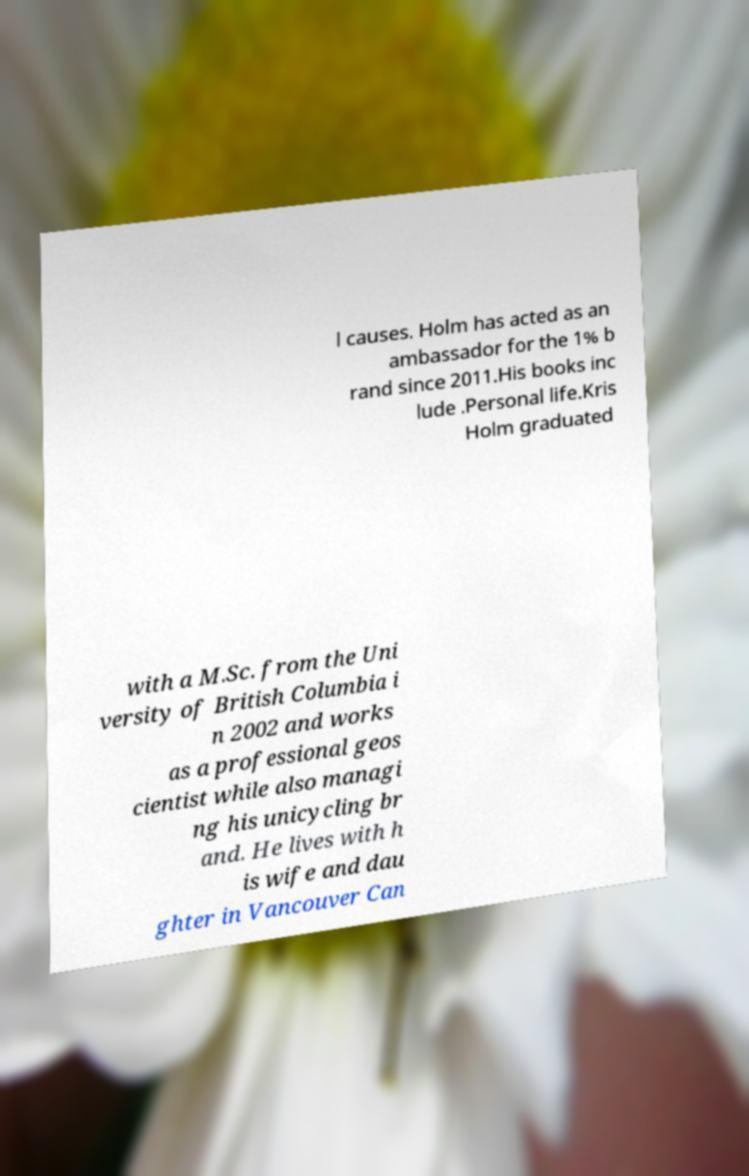Can you read and provide the text displayed in the image?This photo seems to have some interesting text. Can you extract and type it out for me? l causes. Holm has acted as an ambassador for the 1% b rand since 2011.His books inc lude .Personal life.Kris Holm graduated with a M.Sc. from the Uni versity of British Columbia i n 2002 and works as a professional geos cientist while also managi ng his unicycling br and. He lives with h is wife and dau ghter in Vancouver Can 